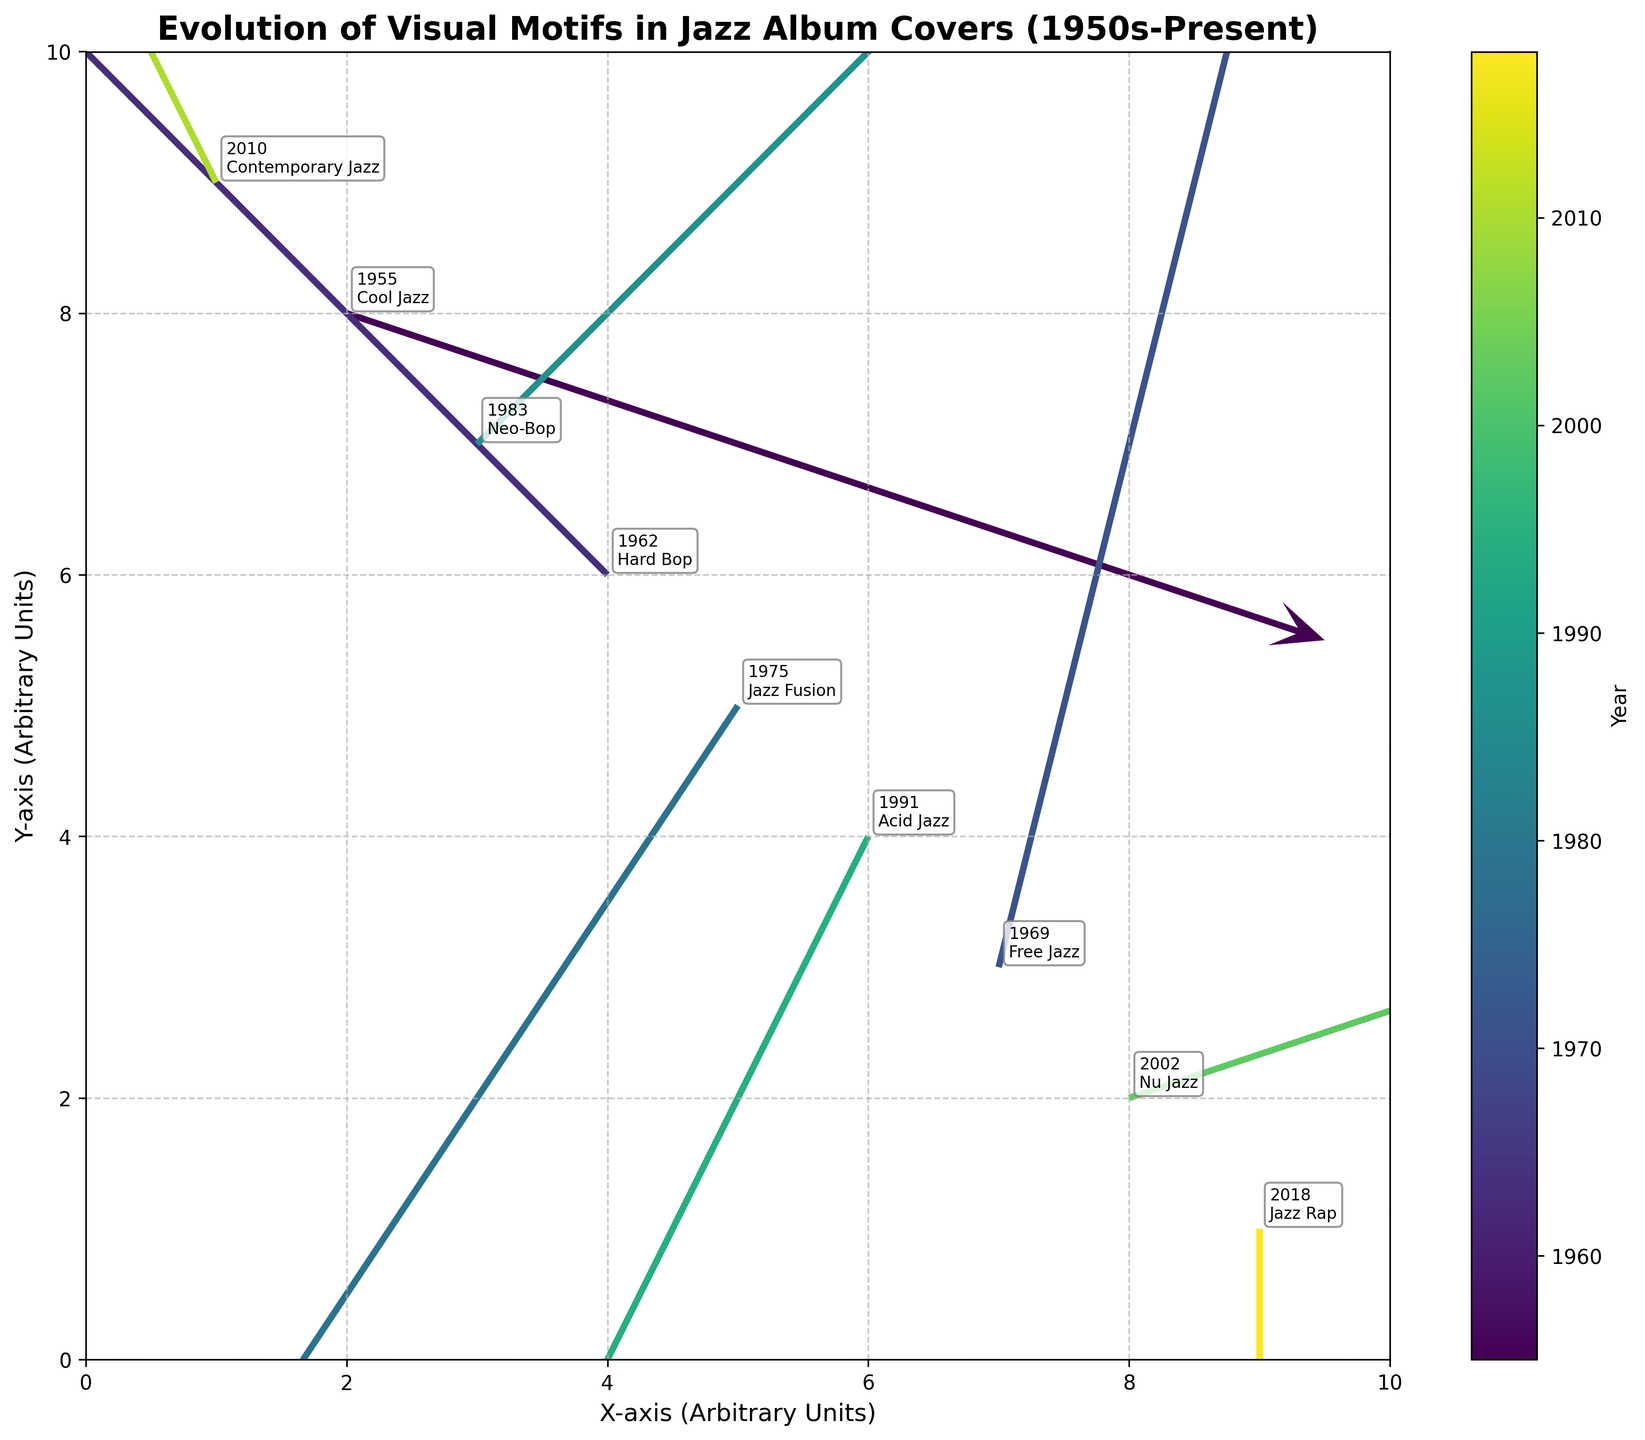How many jazz styles are represented in the figure? By counting the different styles given in the annotations on the figure, we find Cool Jazz, Hard Bop, Free Jazz, Jazz Fusion, Neo-Bop, Acid Jazz, Nu Jazz, Contemporary Jazz, and Jazz Rap.
Answer: 9 What is the title of the figure? The title can be found at the top of the plot. It reads: "Evolution of Visual Motifs in Jazz Album Covers (1950s-Present)"
Answer: Evolution of Visual Motifs in Jazz Album Covers (1950s-Present) Which jazz style shows the most downward direction in visual motifs? Looking at the arrows representing each style, Jazz Rap (2018) shows the most downward direction with a V value of -2.
Answer: Jazz Rap What is the overall trend in visual motif direction from 1955 to 2018? By looking at the figure and observing the general directions of the arrows, we can see a combination of diverse directions without a single dominant trend, indicating a rich evolution with varied movements through time.
Answer: No single dominant trend Which jazz style shows the most upward direction in visual motifs? Observing the arrows, Contemporary Jazz (2010) has the most upward direction with a V value of 2.
Answer: Contemporary Jazz Between 1969 and 1975, which jazz style experienced the greatest change in their visual motif direction? Comparing the arrows for Free Jazz (1969), which moves up with a V value of 2, and Jazz Fusion (1975), which moves down-left with a U and V values of -1 and -1.5 respectively, Jazz Fusion experienced the greatest change in direction.
Answer: Jazz Fusion Which year seems to have a visual motif closest to 1955? By comparing the proximity of points related to years and their corresponding arrows, 1983 (Neo-Bop) with annotations near (3, 7) seems to be the closest to 1955 (Cool Jazz) point near (2, 8).
Answer: 1983 What is the color associated with the year 2018 in the quiver plot? Examining the color bar representing years, the color mapped to 2018 (Jazz Rap) is found at the darker end of the spectrum where the color is dark purple or blue.
Answer: Dark purple/blue 